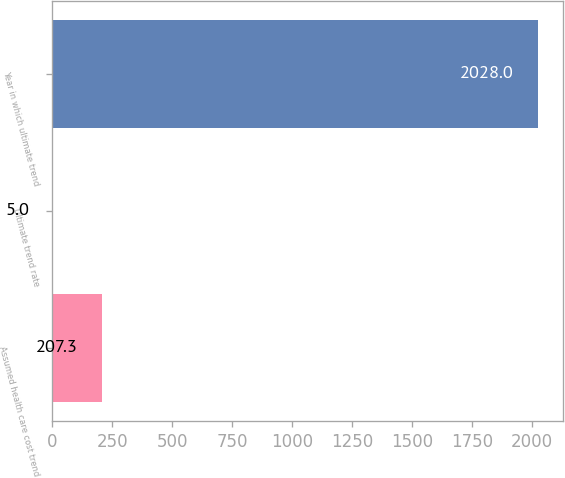Convert chart to OTSL. <chart><loc_0><loc_0><loc_500><loc_500><bar_chart><fcel>Assumed health care cost trend<fcel>Ultimate trend rate<fcel>Year in which ultimate trend<nl><fcel>207.3<fcel>5<fcel>2028<nl></chart> 